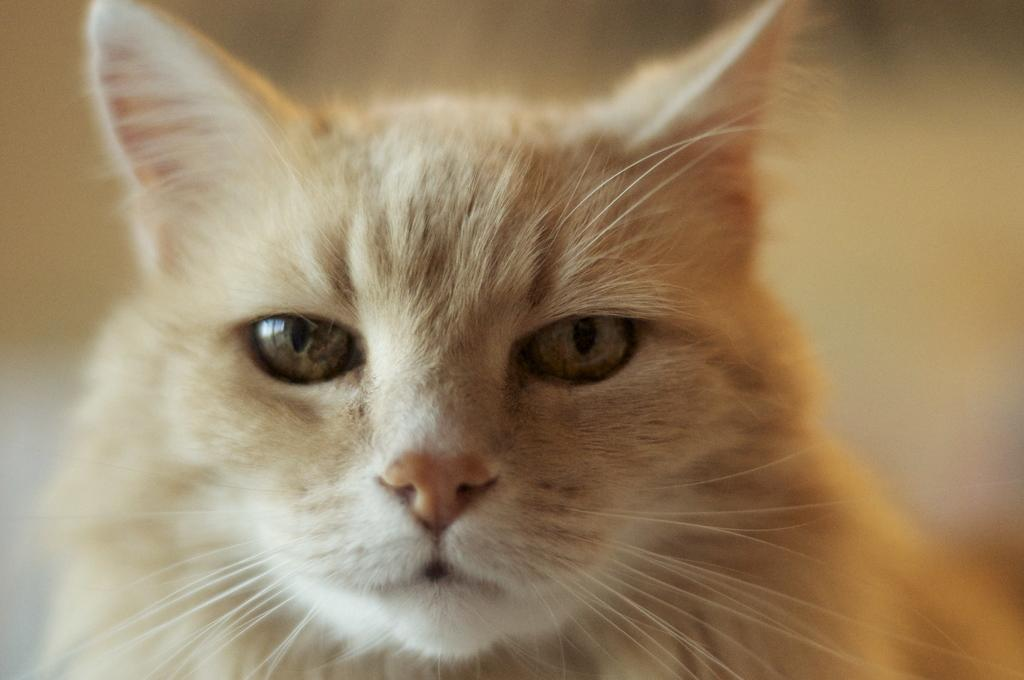What type of animal is present in the image? There is a cat in the image. What type of apparel is the cat wearing in the image? There is no apparel present on the cat in the image. Does the cat's existence in the image prove the existence of extraterrestrial life? The presence of a cat in the image does not prove the existence of extraterrestrial life. 